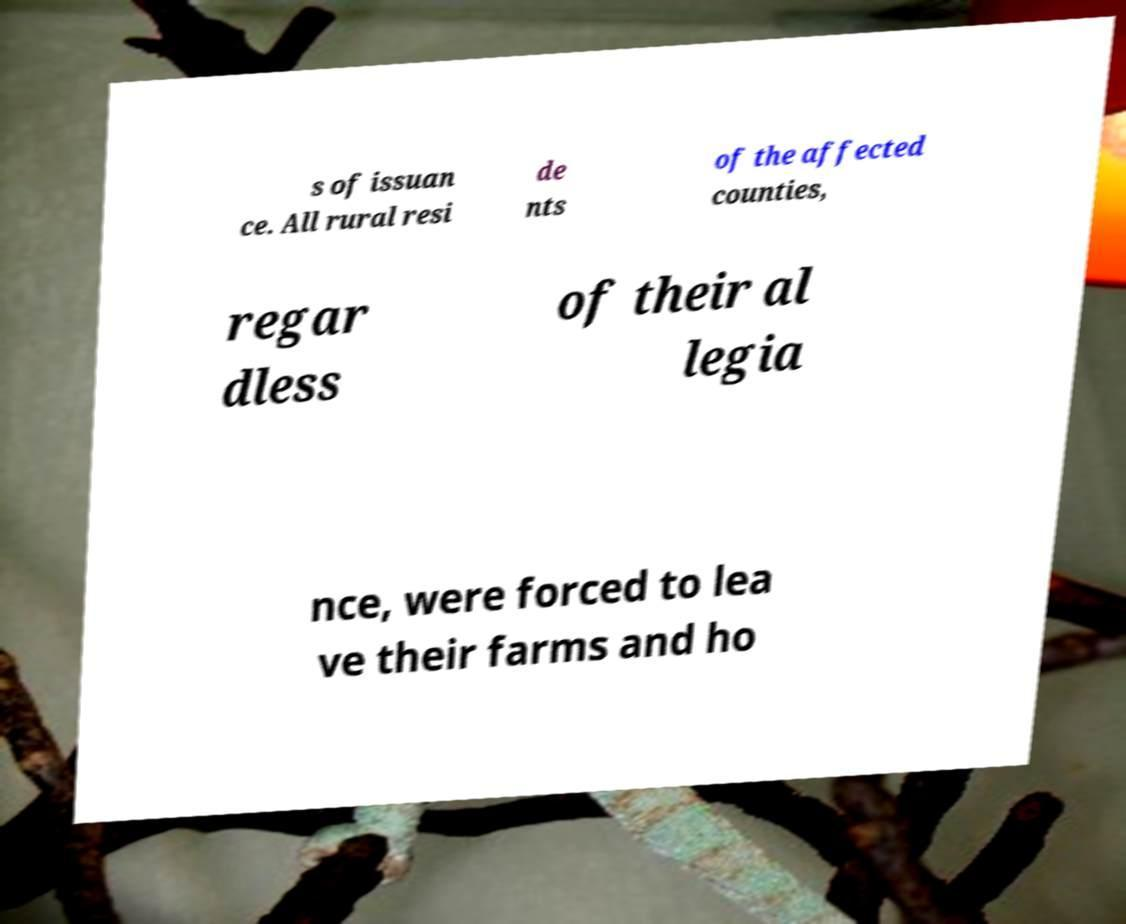I need the written content from this picture converted into text. Can you do that? s of issuan ce. All rural resi de nts of the affected counties, regar dless of their al legia nce, were forced to lea ve their farms and ho 